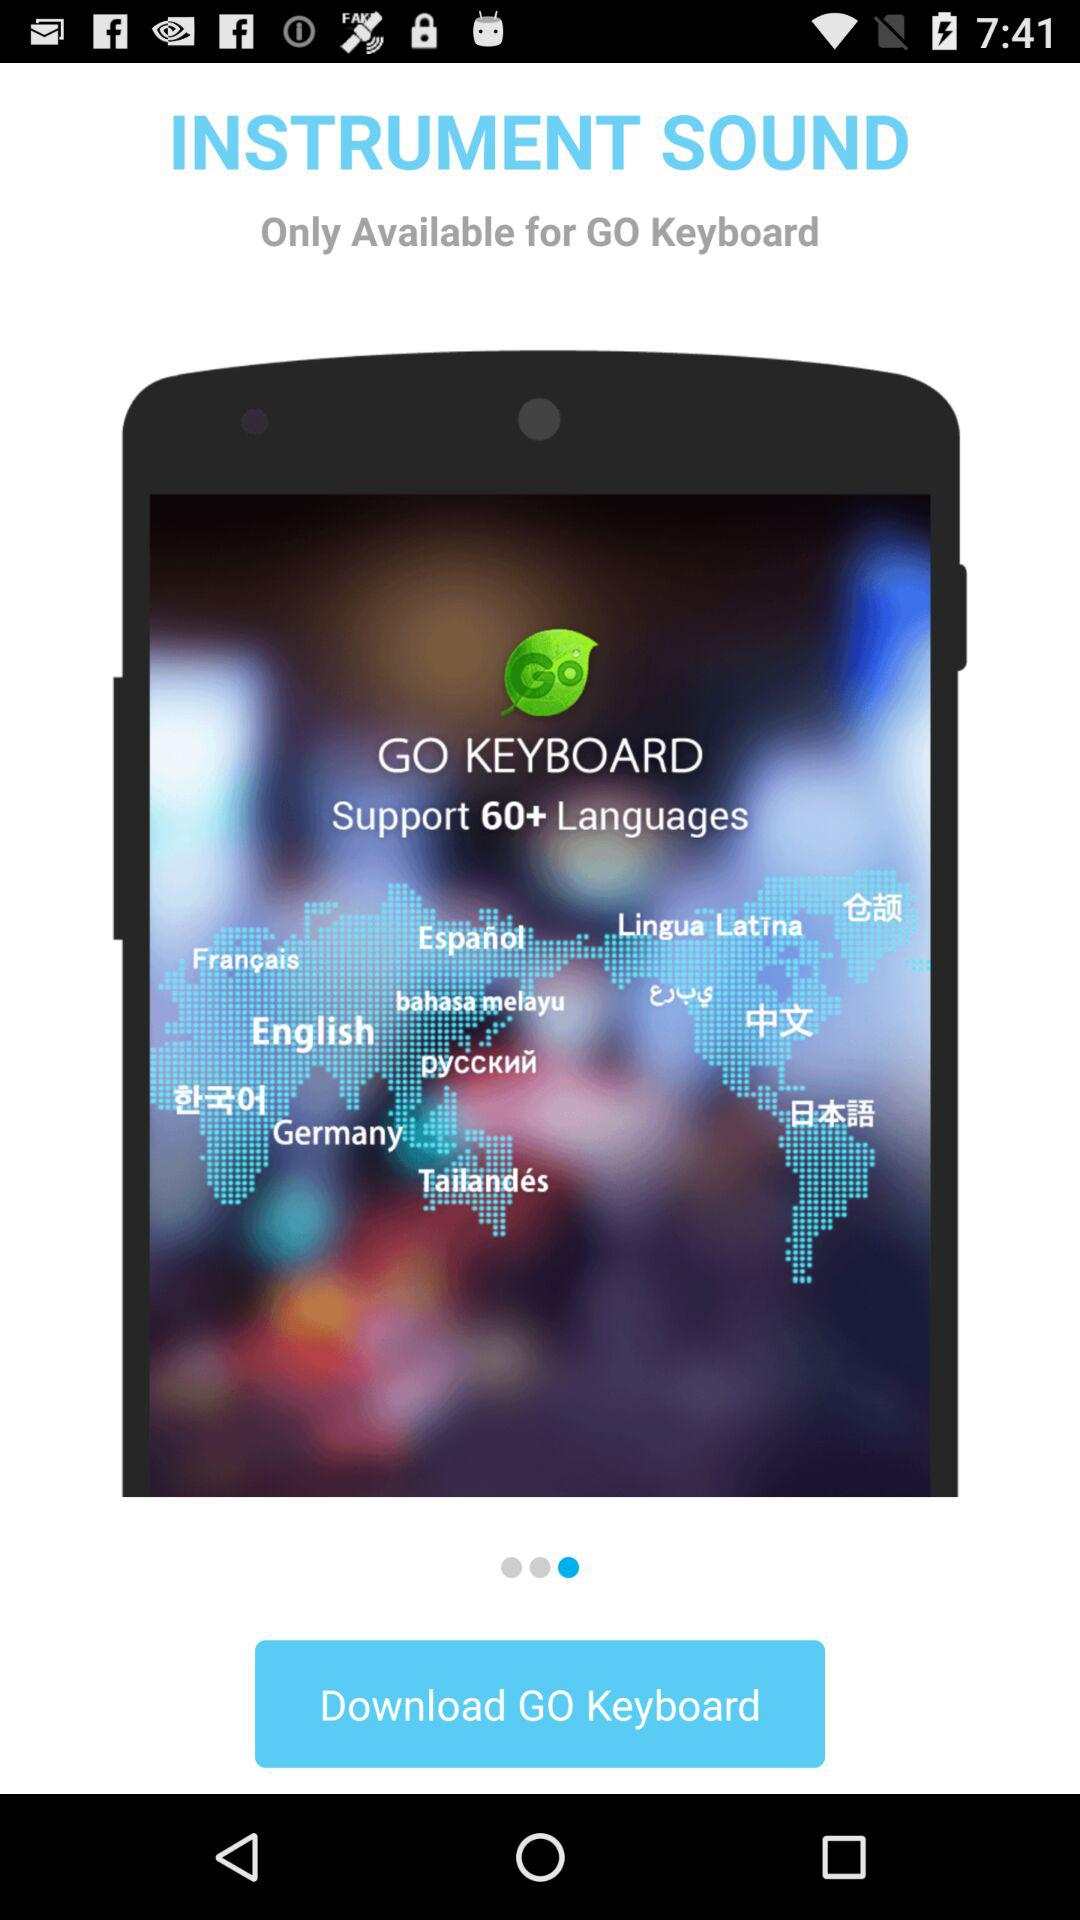What is the name of the application? The name of the application is "GO KEYBOARD". 